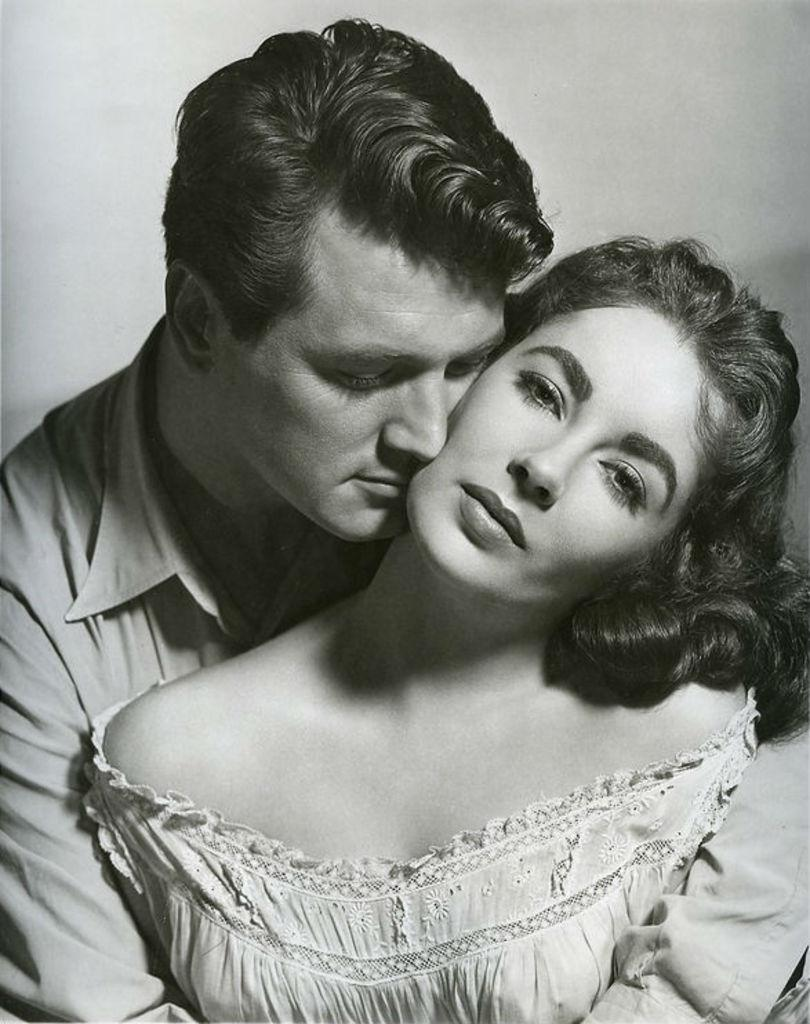How many people are present in the image? There are two people in the image, a man and a woman. What is the color scheme of the image? The image is black and white. What type of toothbrush is the man using in the image? There is no toothbrush present in the image, as it is a black and white photograph featuring a man and a woman. What level of education does the woman have in the image? There is no information about the woman's education level in the image, as it is a black and white photograph featuring a man and a woman. 